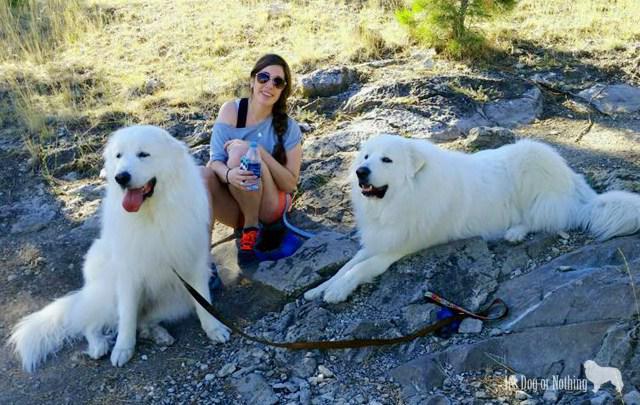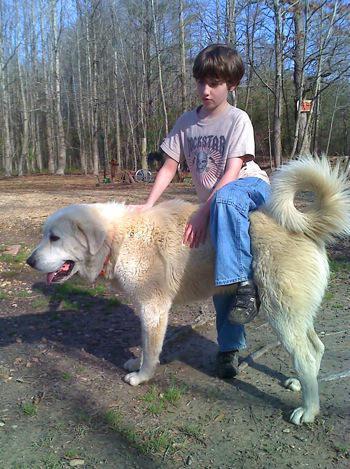The first image is the image on the left, the second image is the image on the right. Considering the images on both sides, is "Right image shows an older person next to a large dog." valid? Answer yes or no. No. The first image is the image on the left, the second image is the image on the right. For the images shown, is this caption "There are at least 3 dogs." true? Answer yes or no. Yes. 